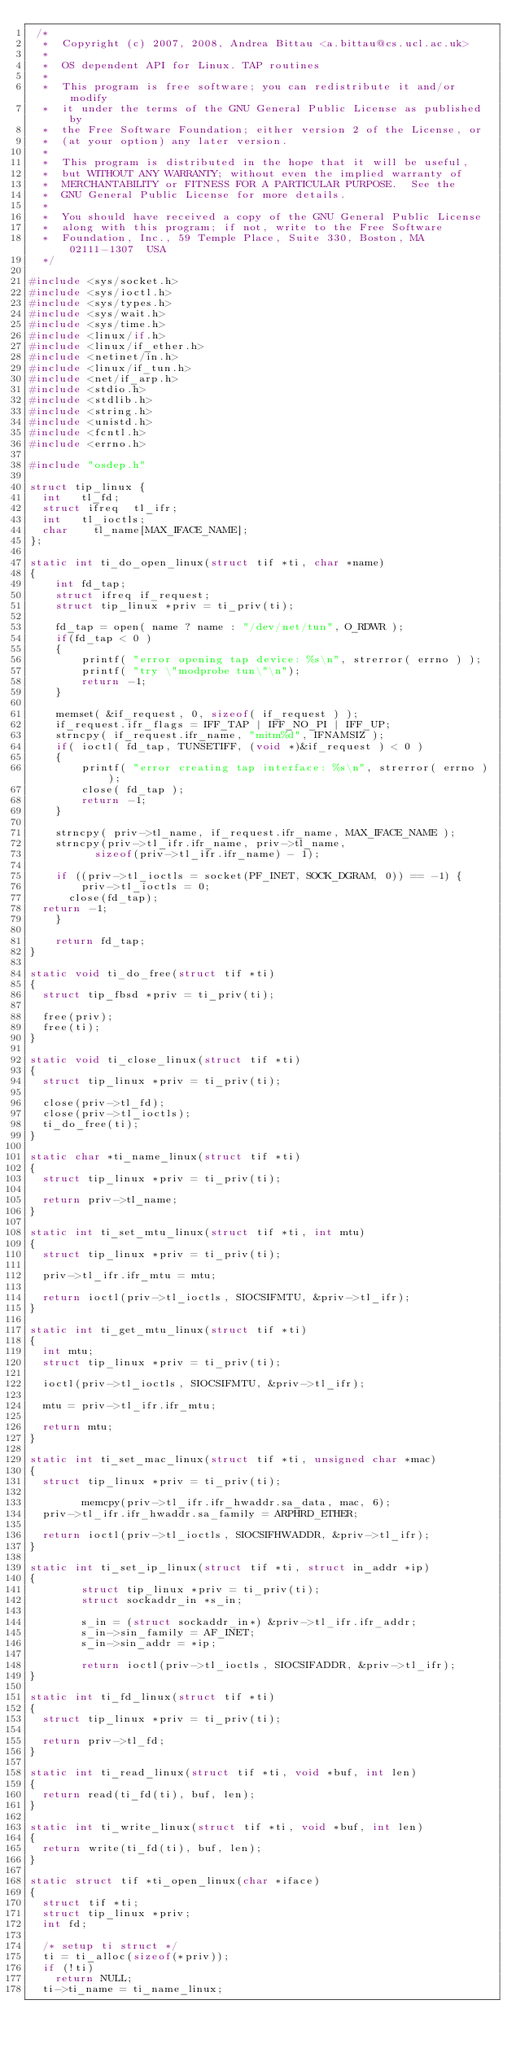<code> <loc_0><loc_0><loc_500><loc_500><_C_> /*
  *  Copyright (c) 2007, 2008, Andrea Bittau <a.bittau@cs.ucl.ac.uk>
  *
  *  OS dependent API for Linux. TAP routines
  *
  *  This program is free software; you can redistribute it and/or modify
  *  it under the terms of the GNU General Public License as published by
  *  the Free Software Foundation; either version 2 of the License, or
  *  (at your option) any later version.
  *
  *  This program is distributed in the hope that it will be useful,
  *  but WITHOUT ANY WARRANTY; without even the implied warranty of
  *  MERCHANTABILITY or FITNESS FOR A PARTICULAR PURPOSE.  See the
  *  GNU General Public License for more details.
  *
  *  You should have received a copy of the GNU General Public License
  *  along with this program; if not, write to the Free Software
  *  Foundation, Inc., 59 Temple Place, Suite 330, Boston, MA  02111-1307  USA
  */

#include <sys/socket.h>
#include <sys/ioctl.h>
#include <sys/types.h>
#include <sys/wait.h>
#include <sys/time.h>
#include <linux/if.h>
#include <linux/if_ether.h>
#include <netinet/in.h>
#include <linux/if_tun.h>
#include <net/if_arp.h>
#include <stdio.h>
#include <stdlib.h>
#include <string.h>
#include <unistd.h>
#include <fcntl.h>
#include <errno.h>

#include "osdep.h"

struct tip_linux {
	int		tl_fd;
	struct ifreq	tl_ifr;
	int		tl_ioctls;
	char		tl_name[MAX_IFACE_NAME];
};

static int ti_do_open_linux(struct tif *ti, char *name)
{
    int fd_tap;
    struct ifreq if_request;
    struct tip_linux *priv = ti_priv(ti);

    fd_tap = open( name ? name : "/dev/net/tun", O_RDWR );
    if(fd_tap < 0 )
    {
        printf( "error opening tap device: %s\n", strerror( errno ) );
        printf( "try \"modprobe tun\"\n");
        return -1;
    }

    memset( &if_request, 0, sizeof( if_request ) );
    if_request.ifr_flags = IFF_TAP | IFF_NO_PI | IFF_UP;
    strncpy( if_request.ifr_name, "mitm%d", IFNAMSIZ );
    if( ioctl( fd_tap, TUNSETIFF, (void *)&if_request ) < 0 )
    {
        printf( "error creating tap interface: %s\n", strerror( errno ) );
        close( fd_tap );
        return -1;
    }

    strncpy( priv->tl_name, if_request.ifr_name, MAX_IFACE_NAME );
    strncpy(priv->tl_ifr.ifr_name, priv->tl_name,
    	    sizeof(priv->tl_ifr.ifr_name) - 1);

    if ((priv->tl_ioctls = socket(PF_INET, SOCK_DGRAM, 0)) == -1) {
        priv->tl_ioctls = 0;
    	close(fd_tap);
	return -1;
    }

    return fd_tap;
}

static void ti_do_free(struct tif *ti)
{
	struct tip_fbsd *priv = ti_priv(ti);

	free(priv);
	free(ti);
}

static void ti_close_linux(struct tif *ti)
{
	struct tip_linux *priv = ti_priv(ti);

	close(priv->tl_fd);
	close(priv->tl_ioctls);
	ti_do_free(ti);
}

static char *ti_name_linux(struct tif *ti)
{
	struct tip_linux *priv = ti_priv(ti);

	return priv->tl_name;
}

static int ti_set_mtu_linux(struct tif *ti, int mtu)
{
	struct tip_linux *priv = ti_priv(ti);

	priv->tl_ifr.ifr_mtu = mtu;

	return ioctl(priv->tl_ioctls, SIOCSIFMTU, &priv->tl_ifr);
}

static int ti_get_mtu_linux(struct tif *ti)
{
	int mtu;
	struct tip_linux *priv = ti_priv(ti);

	ioctl(priv->tl_ioctls, SIOCSIFMTU, &priv->tl_ifr);

	mtu = priv->tl_ifr.ifr_mtu;

	return mtu;
}

static int ti_set_mac_linux(struct tif *ti, unsigned char *mac)
{
	struct tip_linux *priv = ti_priv(ti);

        memcpy(priv->tl_ifr.ifr_hwaddr.sa_data, mac, 6);
	priv->tl_ifr.ifr_hwaddr.sa_family = ARPHRD_ETHER;

	return ioctl(priv->tl_ioctls, SIOCSIFHWADDR, &priv->tl_ifr);
}

static int ti_set_ip_linux(struct tif *ti, struct in_addr *ip)
{
        struct tip_linux *priv = ti_priv(ti);
        struct sockaddr_in *s_in;

        s_in = (struct sockaddr_in*) &priv->tl_ifr.ifr_addr;
        s_in->sin_family = AF_INET;
        s_in->sin_addr = *ip;

        return ioctl(priv->tl_ioctls, SIOCSIFADDR, &priv->tl_ifr);
}

static int ti_fd_linux(struct tif *ti)
{
	struct tip_linux *priv = ti_priv(ti);

	return priv->tl_fd;
}

static int ti_read_linux(struct tif *ti, void *buf, int len)
{
	return read(ti_fd(ti), buf, len);
}

static int ti_write_linux(struct tif *ti, void *buf, int len)
{
	return write(ti_fd(ti), buf, len);
}

static struct tif *ti_open_linux(char *iface)
{
	struct tif *ti;
	struct tip_linux *priv;
	int fd;

	/* setup ti struct */
	ti = ti_alloc(sizeof(*priv));
	if (!ti)
		return NULL;
	ti->ti_name	= ti_name_linux;</code> 